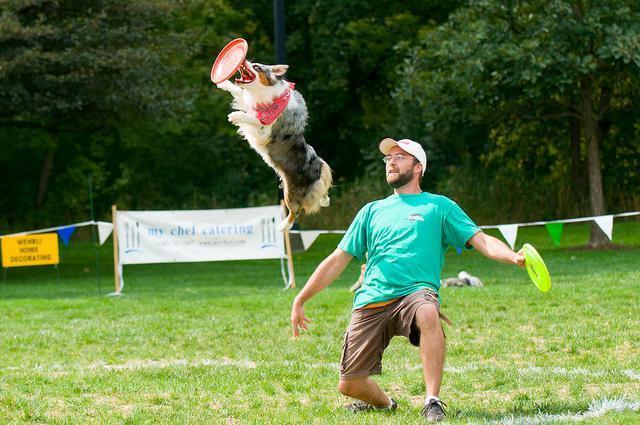How many black horse are there in the image ?
Give a very brief answer. 0. 